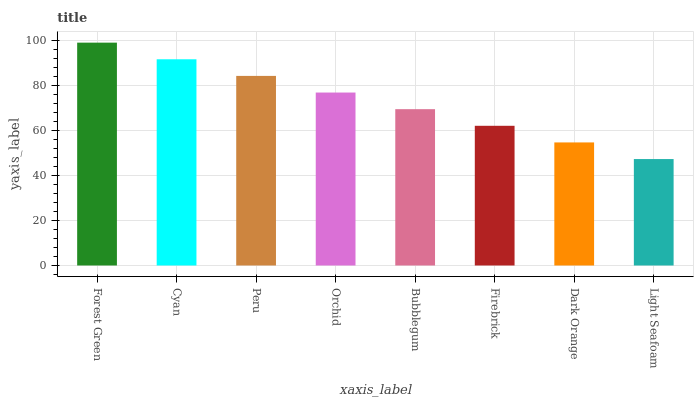Is Light Seafoam the minimum?
Answer yes or no. Yes. Is Forest Green the maximum?
Answer yes or no. Yes. Is Cyan the minimum?
Answer yes or no. No. Is Cyan the maximum?
Answer yes or no. No. Is Forest Green greater than Cyan?
Answer yes or no. Yes. Is Cyan less than Forest Green?
Answer yes or no. Yes. Is Cyan greater than Forest Green?
Answer yes or no. No. Is Forest Green less than Cyan?
Answer yes or no. No. Is Orchid the high median?
Answer yes or no. Yes. Is Bubblegum the low median?
Answer yes or no. Yes. Is Peru the high median?
Answer yes or no. No. Is Cyan the low median?
Answer yes or no. No. 